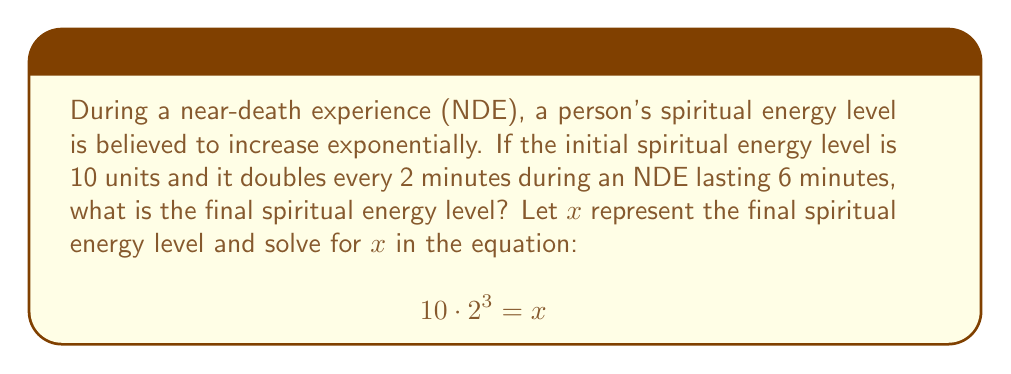Help me with this question. Let's solve this step-by-step:

1) First, we need to understand what the equation represents:
   - 10 is the initial spiritual energy level
   - $2^3$ represents the doubling that occurs 3 times (once every 2 minutes for 6 minutes)
   - $x$ is the final spiritual energy level we're solving for

2) Now, let's simplify the left side of the equation:
   $$10 \cdot 2^3 = 10 \cdot 8 = 80$$

3) So our equation becomes:
   $$80 = x$$

4) Therefore, $x$ is equal to 80.

This means the final spiritual energy level after the 6-minute NDE is 80 units.
Answer: $x = 80$ 